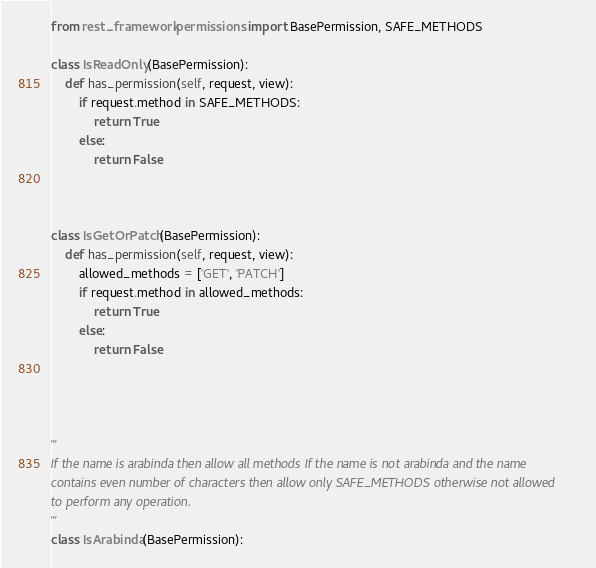Convert code to text. <code><loc_0><loc_0><loc_500><loc_500><_Python_>from rest_framework.permissions import BasePermission, SAFE_METHODS

class IsReadOnly(BasePermission):
	def has_permission(self, request, view):
		if request.method in SAFE_METHODS:
			return True
		else:
			return False



class IsGetOrPatch(BasePermission):
	def has_permission(self, request, view):
		allowed_methods = ['GET', 'PATCH']
		if request.method in allowed_methods:
			return True
		else:
			return False




'''
If the name is arabinda then allow all methods If the name is not arabinda and the name 
contains even number of characters then allow only SAFE_METHODS otherwise not allowed 
to perform any operation.
'''
class IsArabinda(BasePermission):</code> 